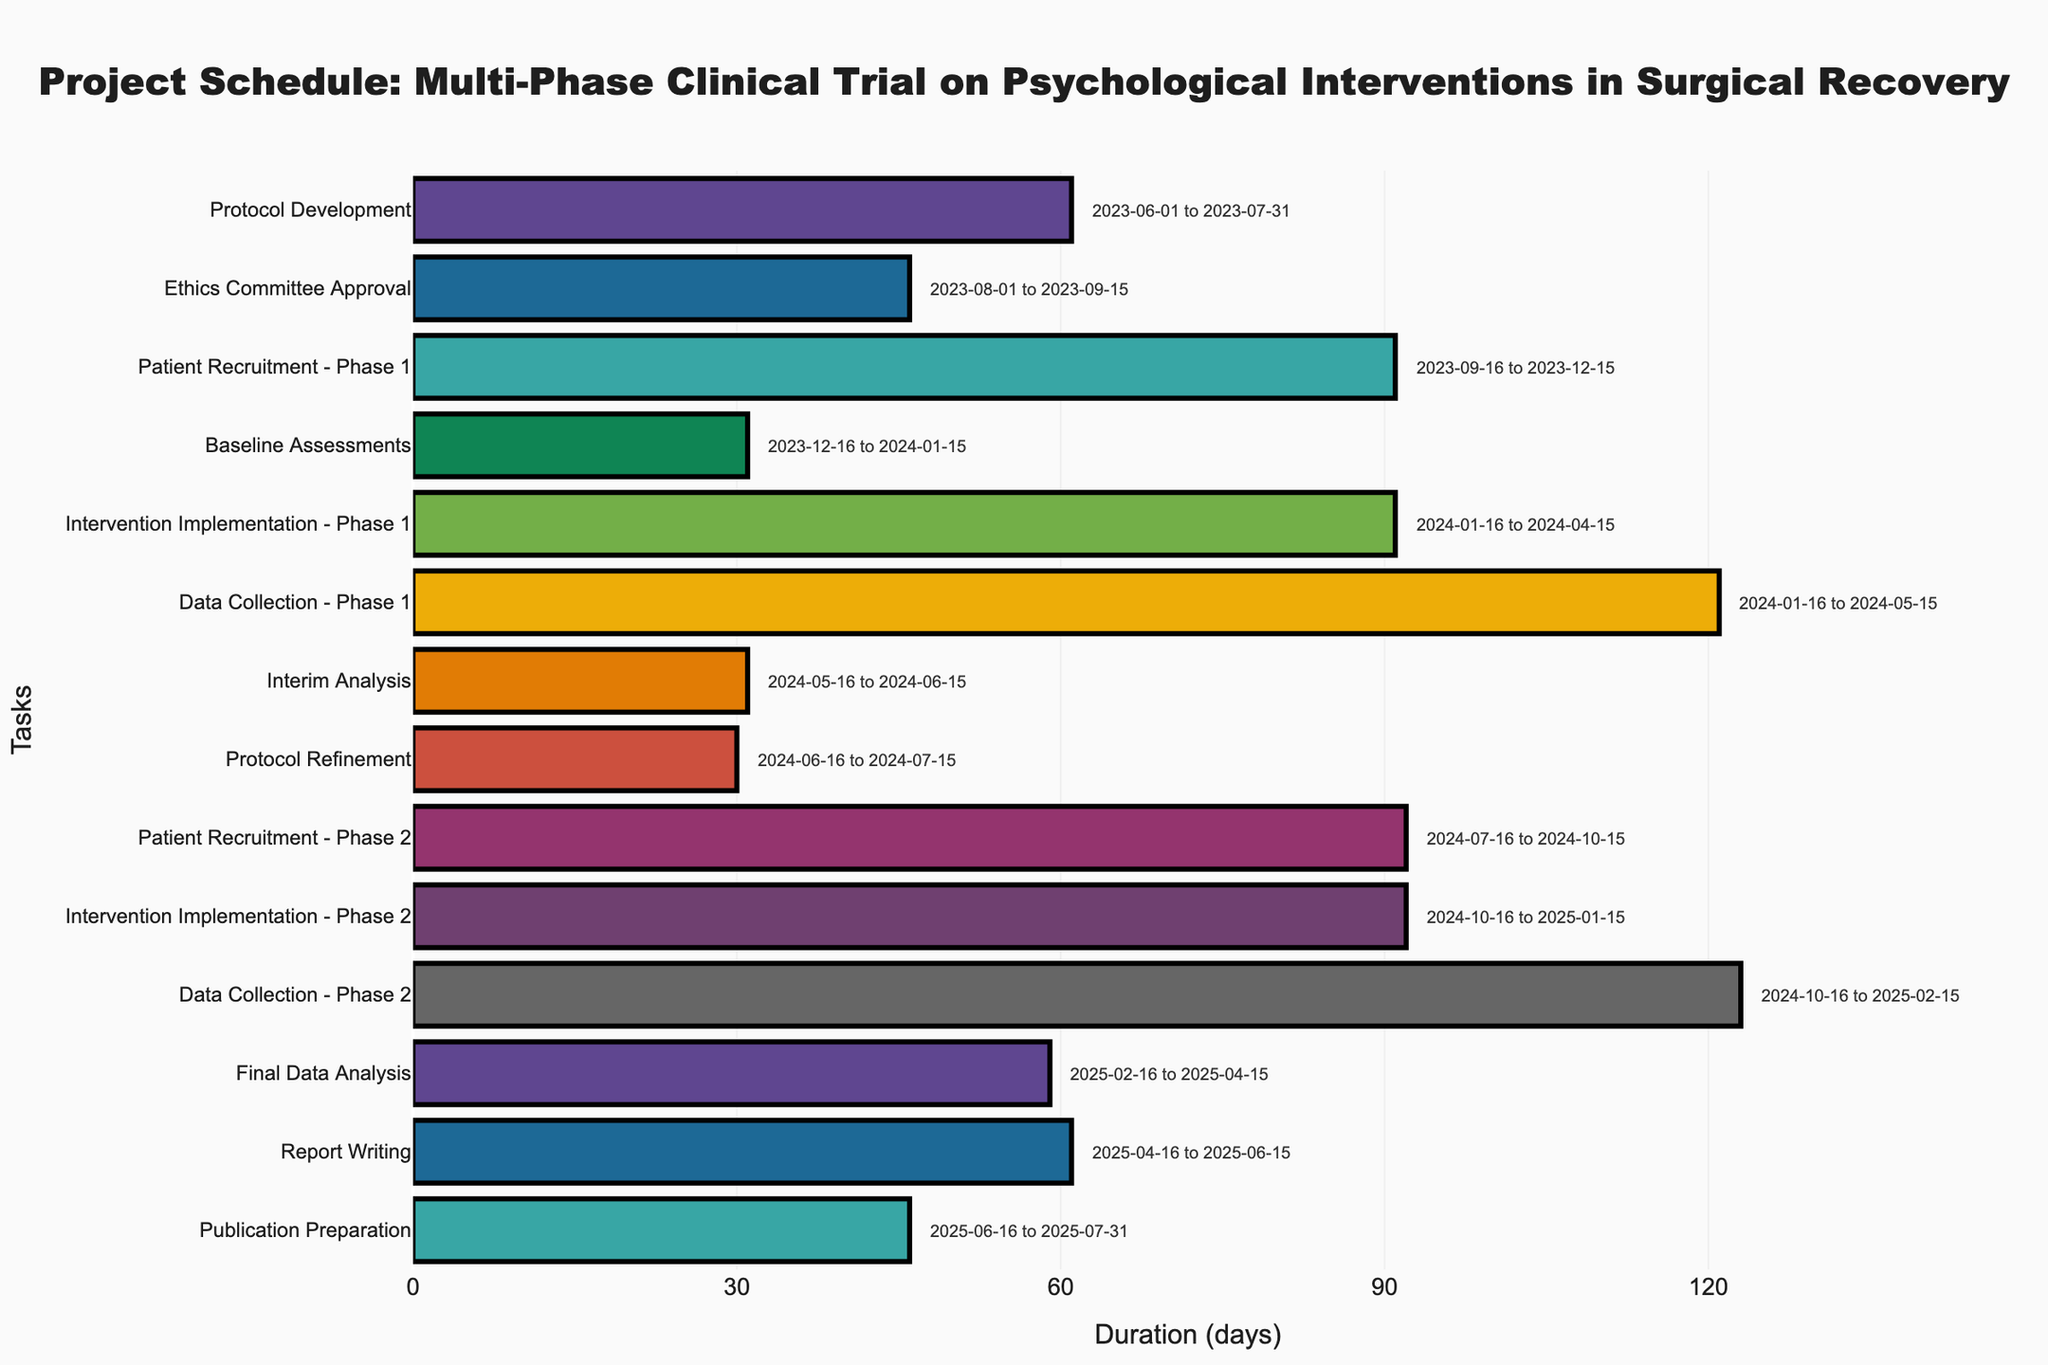What is the title of the chart? The title is displayed at the top of the chart and describes the figure's main purpose, which in this case is to show the project schedule for a multi-phase clinical trial.
Answer: Project Schedule: Multi-Phase Clinical Trial on Psychological Interventions in Surgical Recovery How many tasks are represented in the Gantt Chart? Count the number of bars or task names on the y-axis to determine the total number of tasks represented.
Answer: 14 Which task has the longest duration and what is its duration? Compare the lengths of the bars to find the longest one. The bar with the longest length corresponds to the task with the longest duration.
Answer: Data Collection - Phase 2, 123 days Which tasks overlap during the timeline from January 16, 2024, to April 15, 2024? Identify tasks whose bars are aligned horizontally with the timeline from January 16, 2024, to April 15, 2024.
Answer: Intervention Implementation - Phase 1, Data Collection - Phase 1 What is the combined duration of 'Patient Recruitment - Phase 1' and 'Patient Recruitment - Phase 2'? Sum the duration of both tasks: Patient Recruitment - Phase 1 (91 days) and Patient Recruitment - Phase 2 (92 days).
Answer: 183 days Which phase has the longer total implementation period: Phase 1 or Phase 2? Sum the durations for 'Intervention Implementation' and 'Data Collection' for both phases separately. Compare the sums.
Answer: Phase 2 What task follows directly after 'Intervention Implementation - Phase 1'? Identify the task that starts immediately after the end date of 'Intervention Implementation - Phase 1'.
Answer: Data Collection - Phase 1 How long after the start of the project does 'Interim Analysis' begin? Calculate the days between the start date of the first task and the start date of 'Interim Analysis': June 1, 2023, to May 16, 2024.
Answer: 350 days What is the duration overlap between 'Data Collection - Phase 1' and 'Intervention Implementation - Phase 2'? Identify the overlapping period between 'Data Collection - Phase 1' (Jan 16, 2024 to May 15, 2024) and 'Intervention Implementation - Phase 2' (Oct 16, 2024 to Jan 15, 2025).
Answer: No overlap Which tasks conclude in July 2025? Find the tasks that end in July 2025 by looking at the end dates.
Answer: Publication Preparation 